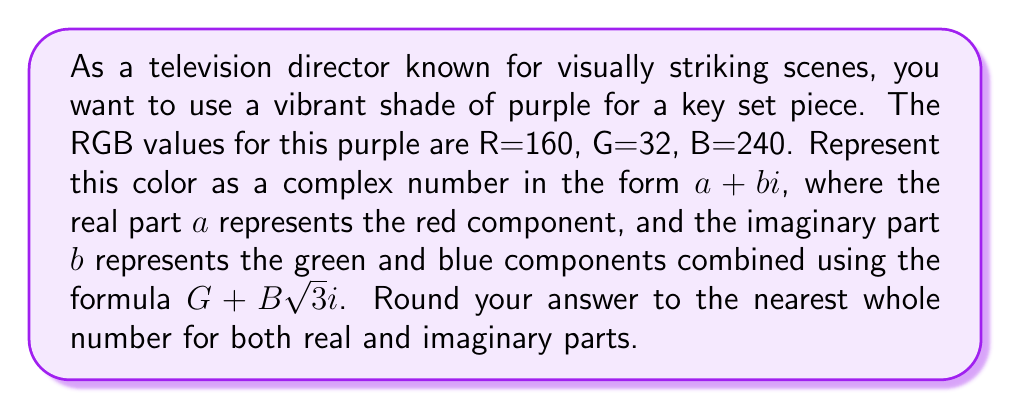Show me your answer to this math problem. To represent the RGB color as a complex number, we'll follow these steps:

1) The real part $a$ is simply the Red value:
   $a = 160$

2) For the imaginary part $b$, we need to combine Green and Blue using the formula $G + B\sqrt{3}i$:
   $b = 32 + 240\sqrt{3}$

3) Simplify the imaginary part:
   $32 + 240\sqrt{3} \approx 32 + 240 \cdot 1.732 \approx 32 + 415.68 \approx 447.68$

4) Round both parts to the nearest whole number:
   Real part: 160 (already a whole number)
   Imaginary part: 448 (rounded from 447.68)

Therefore, the complex number representation is $160 + 448i$.
Answer: $160 + 448i$ 